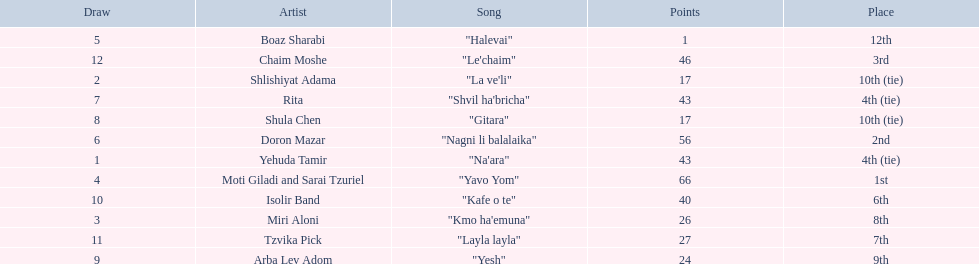What are the points in the competition? 43, 17, 26, 66, 1, 56, 43, 17, 24, 40, 27, 46. What is the lowest points? 1. What artist received these points? Boaz Sharabi. 